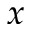Convert formula to latex. <formula><loc_0><loc_0><loc_500><loc_500>x</formula> 